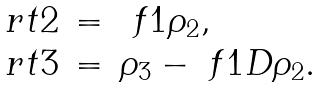Convert formula to latex. <formula><loc_0><loc_0><loc_500><loc_500>\begin{array} { l l l } \ r t { 2 } & = & \ f { 1 } \rho _ { 2 } , \\ \ r t { 3 } & = & \rho _ { 3 } - \ f { 1 } D \rho _ { 2 } . \end{array}</formula> 